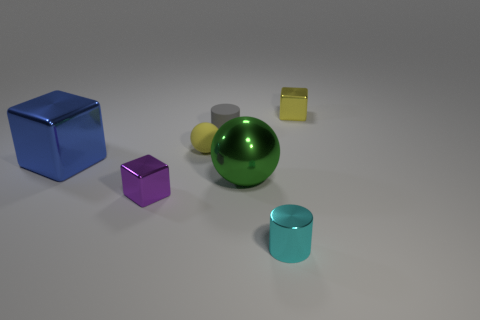Subtract all brown blocks. Subtract all green cylinders. How many blocks are left? 3 Add 1 tiny purple metal objects. How many objects exist? 8 Subtract all blocks. How many objects are left? 4 Subtract all small yellow rubber balls. Subtract all small gray rubber cylinders. How many objects are left? 5 Add 6 yellow rubber spheres. How many yellow rubber spheres are left? 7 Add 7 large blue objects. How many large blue objects exist? 8 Subtract 0 red cylinders. How many objects are left? 7 